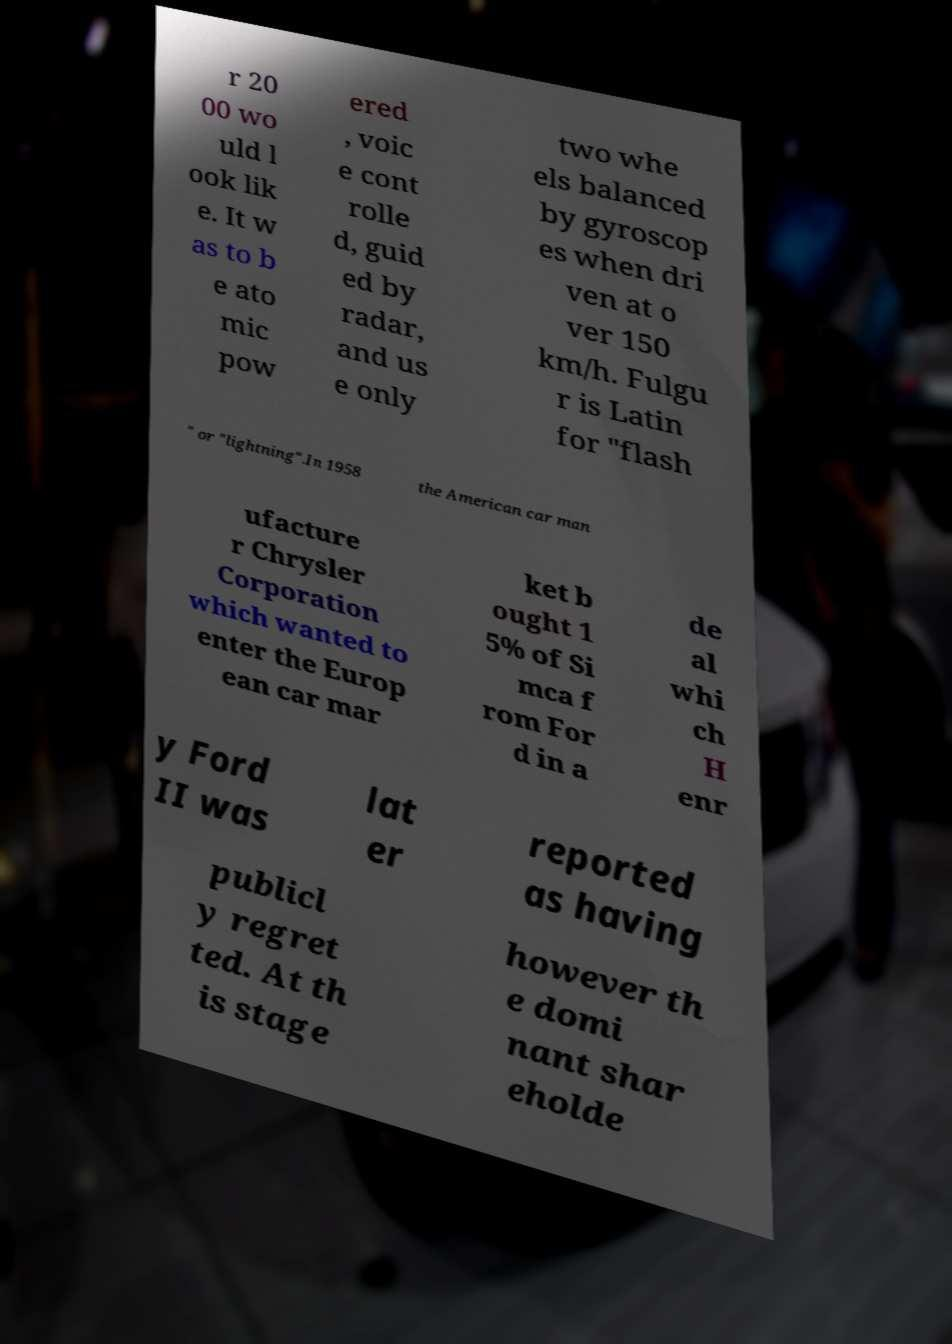Can you read and provide the text displayed in the image?This photo seems to have some interesting text. Can you extract and type it out for me? r 20 00 wo uld l ook lik e. It w as to b e ato mic pow ered , voic e cont rolle d, guid ed by radar, and us e only two whe els balanced by gyroscop es when dri ven at o ver 150 km/h. Fulgu r is Latin for "flash " or "lightning".In 1958 the American car man ufacture r Chrysler Corporation which wanted to enter the Europ ean car mar ket b ought 1 5% of Si mca f rom For d in a de al whi ch H enr y Ford II was lat er reported as having publicl y regret ted. At th is stage however th e domi nant shar eholde 